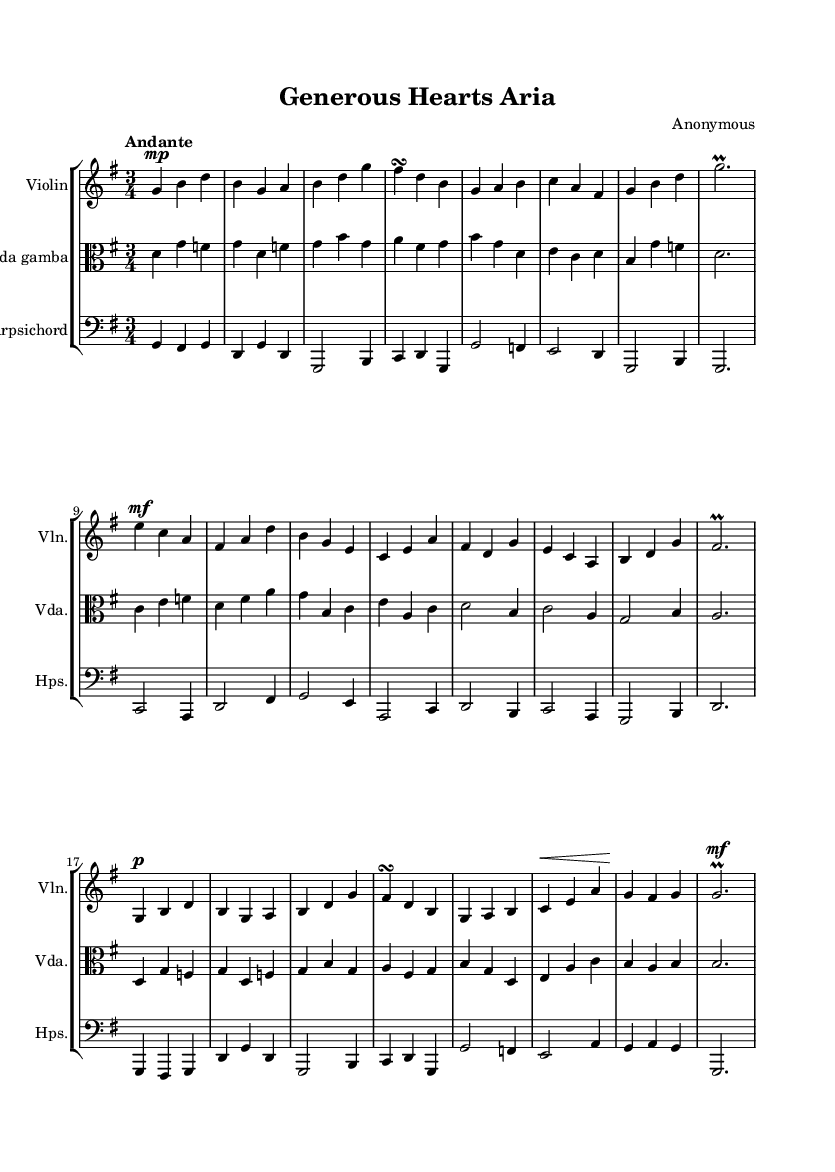What is the key signature of this music? The key signature indicated in the staff shows one sharp, which represents G major.
Answer: G major What is the time signature of this piece? The time signature displayed at the beginning of the score is three beats per measure, which is represented as 3/4.
Answer: 3/4 What is the tempo marking of the piece? The tempo marking at the top of the score states "Andante," which describes the speed of the music as moderately slow.
Answer: Andante In what form is the music structured? The music is divided into sections labeled A, B, and A', indicating a ternary form where the initial theme is repeated after a contrasting section.
Answer: Ternary What dynamic marking is given for the A section? The A section begins with the marking "mp," which instructs the musician to play it moderately softly.
Answer: mp How many measures are in the B section? The B section consists of six measures, as indicated by the number of four-beat units present in that section of the score.
Answer: 6 measures What instruments are featured in this composition? The composition includes three instruments: Violin, Viola da gamba, and Harpsichord, as noted at the beginning of each respective staff.
Answer: Violin, Viola da gamba, Harpsichord 